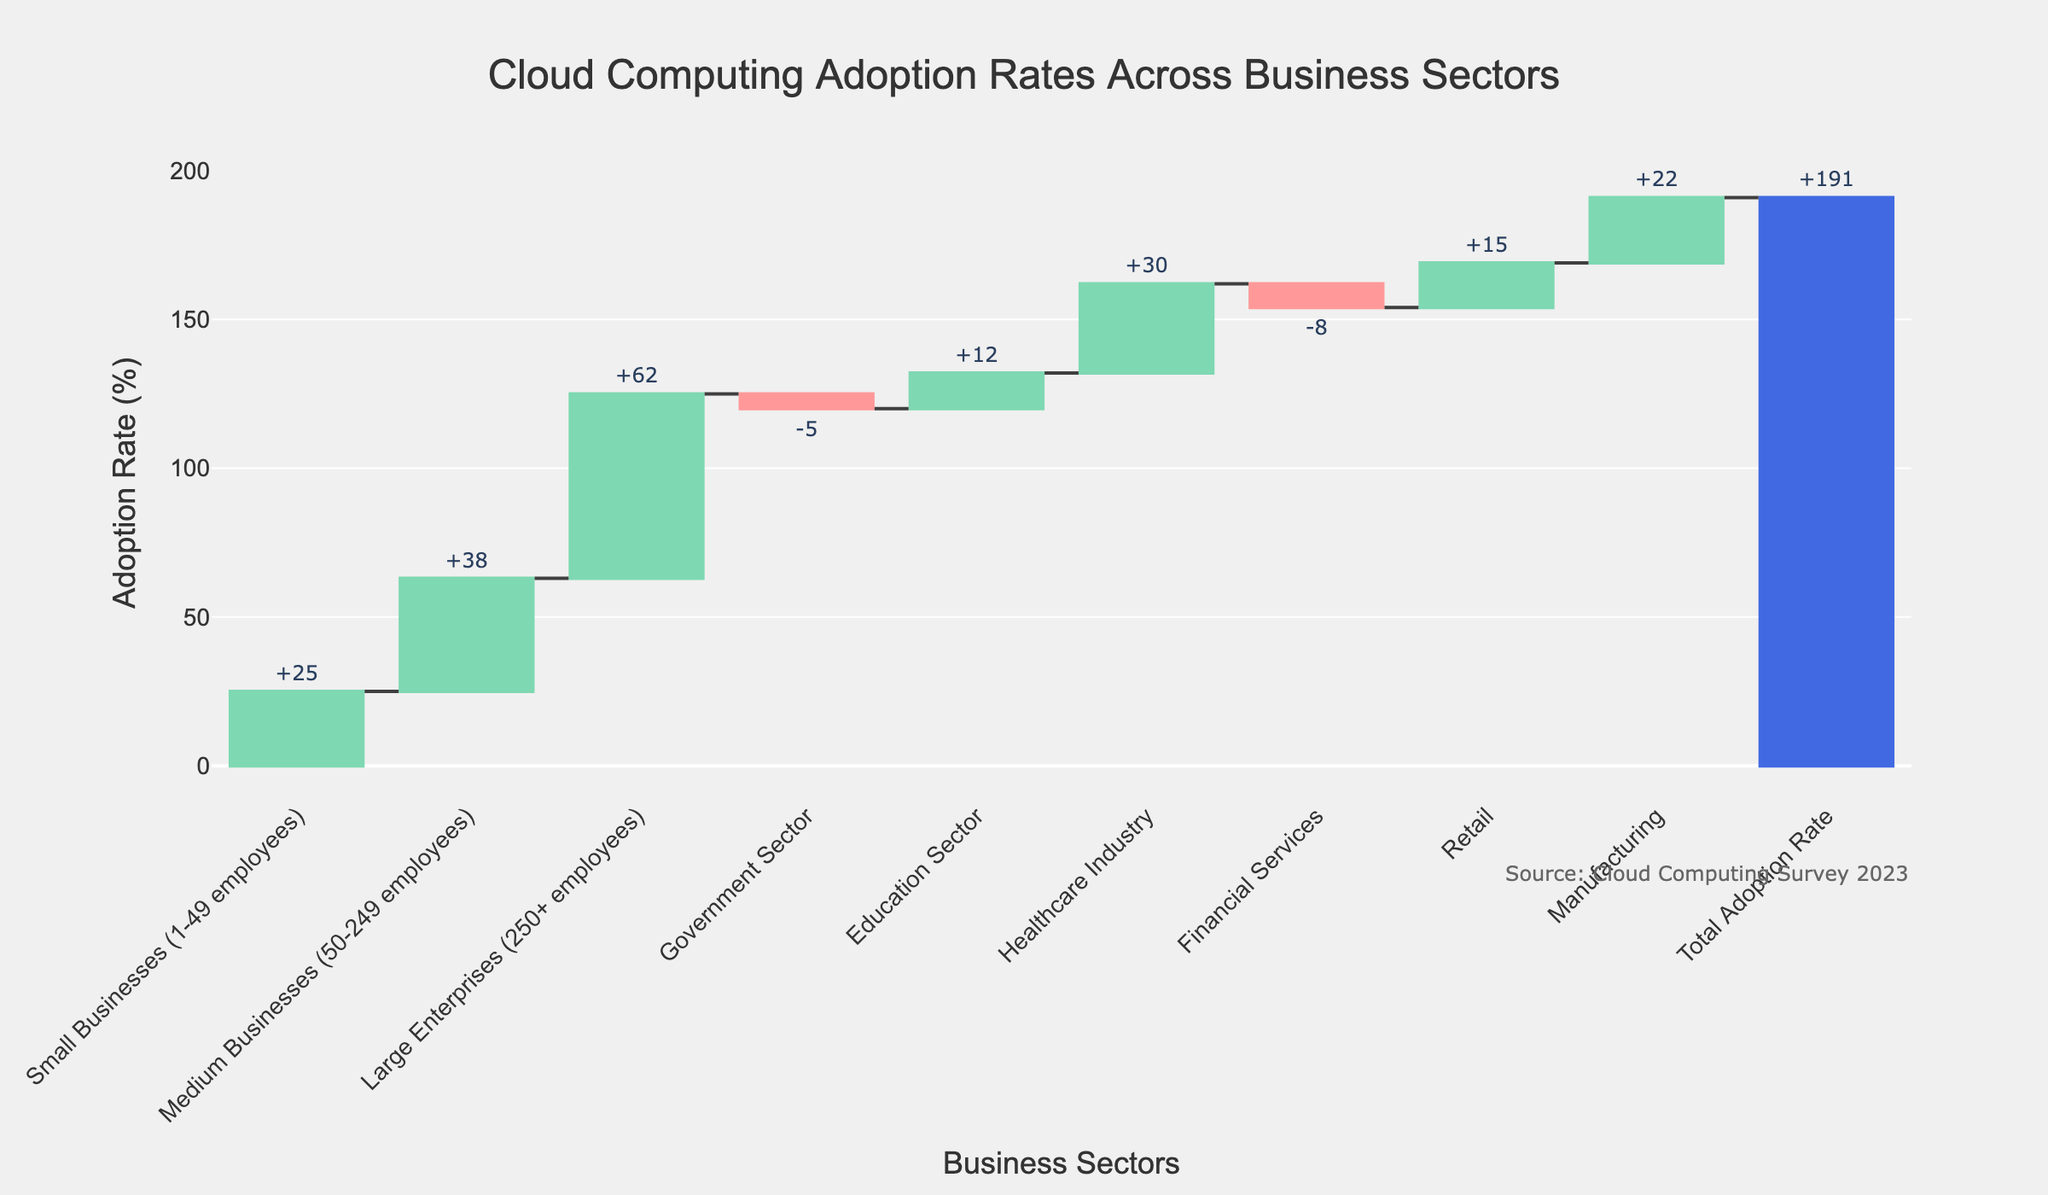What's the title of the figure? The title is usually displayed prominently at the top of the chart. By looking at it, you can identify the main subject of the chart.
Answer: Cloud Computing Adoption Rates Across Business Sectors How many sectors are displayed in the chart? Count the different categories on the x-axis to determine the number of sectors represented in the chart.
Answer: 9 Which business size has the highest cloud computing adoption rate? Identify the tallest increasing bar on the chart and note its corresponding category on the x-axis.
Answer: Large Enterprises (250+ employees) What category shows the highest negative impact on overall adoption rates? Look for the category with the tallest decreasing bar and check its label.
Answer: Financial Services What is the total cloud computing adoption rate? Check the final bar at the end of the chart which represents the total value and read the associated label.
Answer: 191% What is the difference in adoption rates between Small Businesses and Large Enterprises? Subtract the adoption rate of Small Businesses from that of Large Enterprises: 62% - 25% = 37%.
Answer: 37% Which sector contributes a 12% increase to the adoption rate? Identify the bar that is marked with a 12% increase and refer to its label on the x-axis.
Answer: Education Sector How many sectors have a positive impact on the adoption rates? Count the number of bars that are increasing (above the baseline) to determine this.
Answer: 6 What is the combined adoption rate contribution of the Manufacturing and Retail sectors? Add the values of the Manufacturing and Retail sectors together: 22% + 15% = 37%.
Answer: 37% Which sector contributes less to the adoption rate, Healthcare Industry or Education Sector? Compare the height of the bars representing Healthcare Industry and Education Sector and note which one is smaller.
Answer: Education Sector 